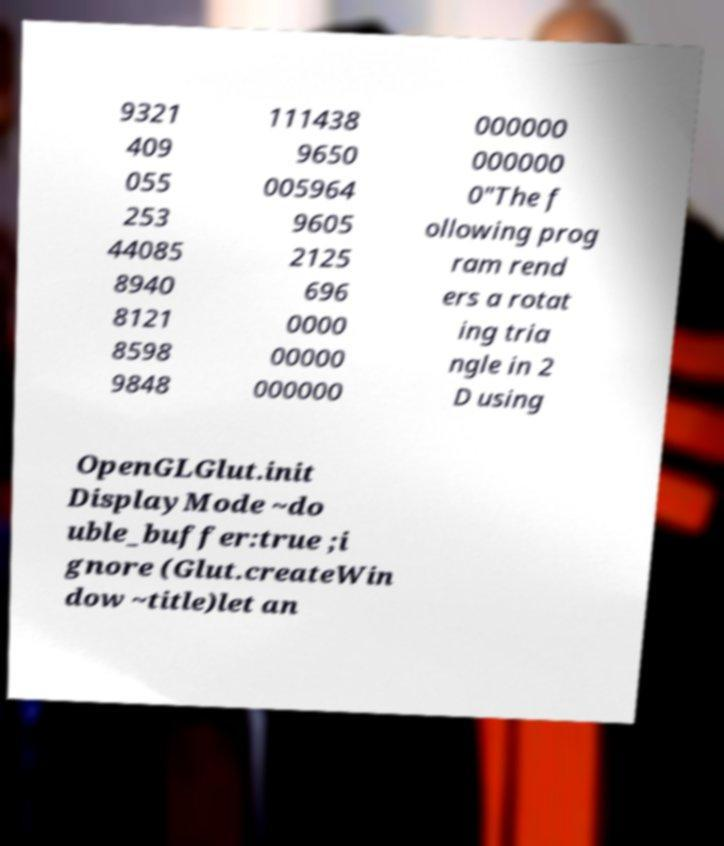Can you accurately transcribe the text from the provided image for me? 9321 409 055 253 44085 8940 8121 8598 9848 111438 9650 005964 9605 2125 696 0000 00000 000000 000000 000000 0"The f ollowing prog ram rend ers a rotat ing tria ngle in 2 D using OpenGLGlut.init DisplayMode ~do uble_buffer:true ;i gnore (Glut.createWin dow ~title)let an 